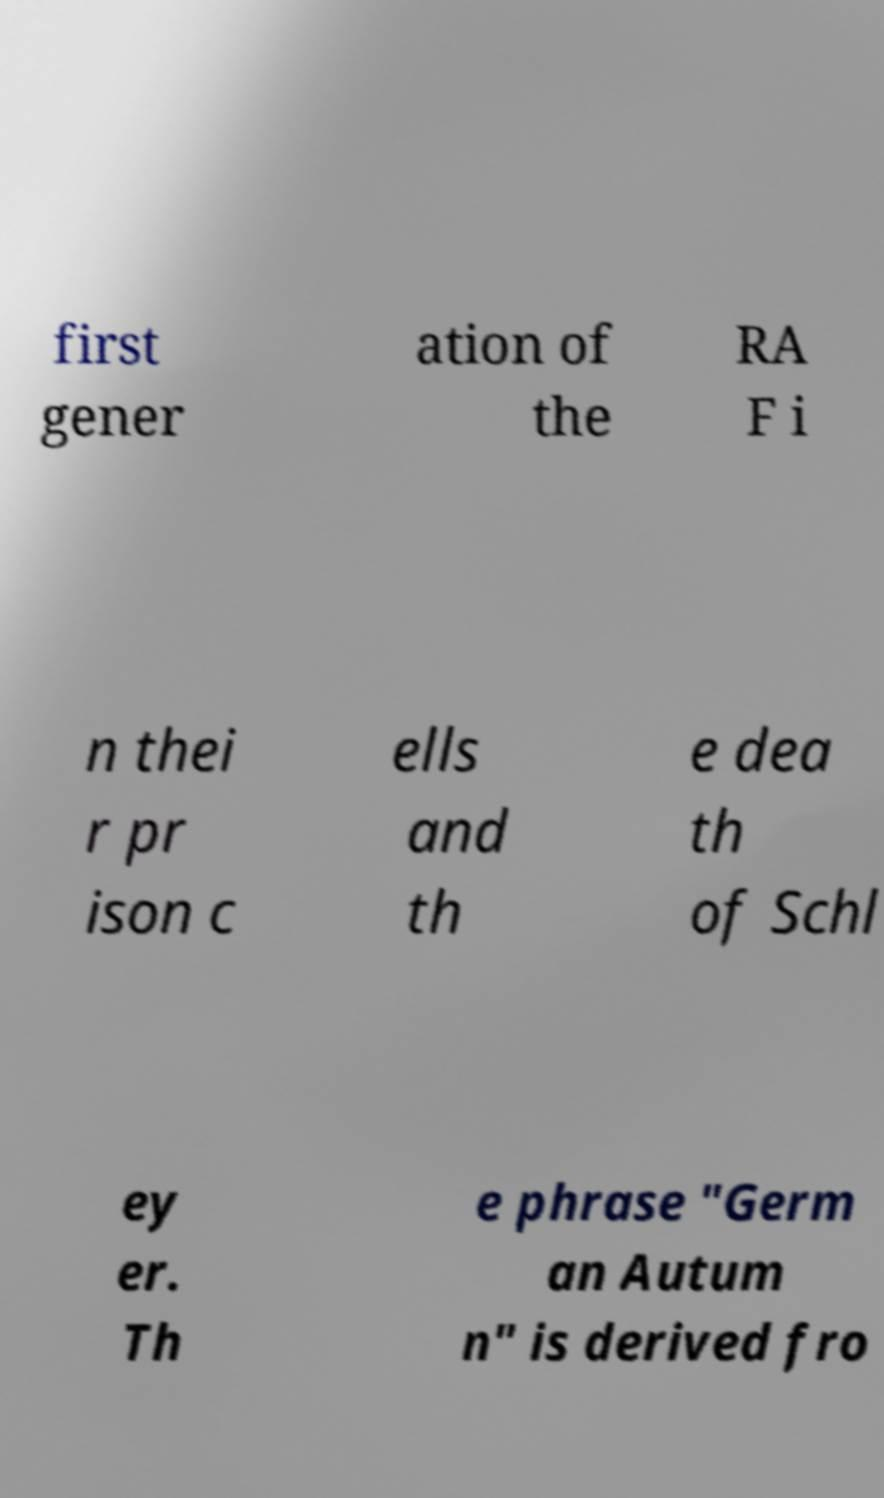Could you assist in decoding the text presented in this image and type it out clearly? first gener ation of the RA F i n thei r pr ison c ells and th e dea th of Schl ey er. Th e phrase "Germ an Autum n" is derived fro 